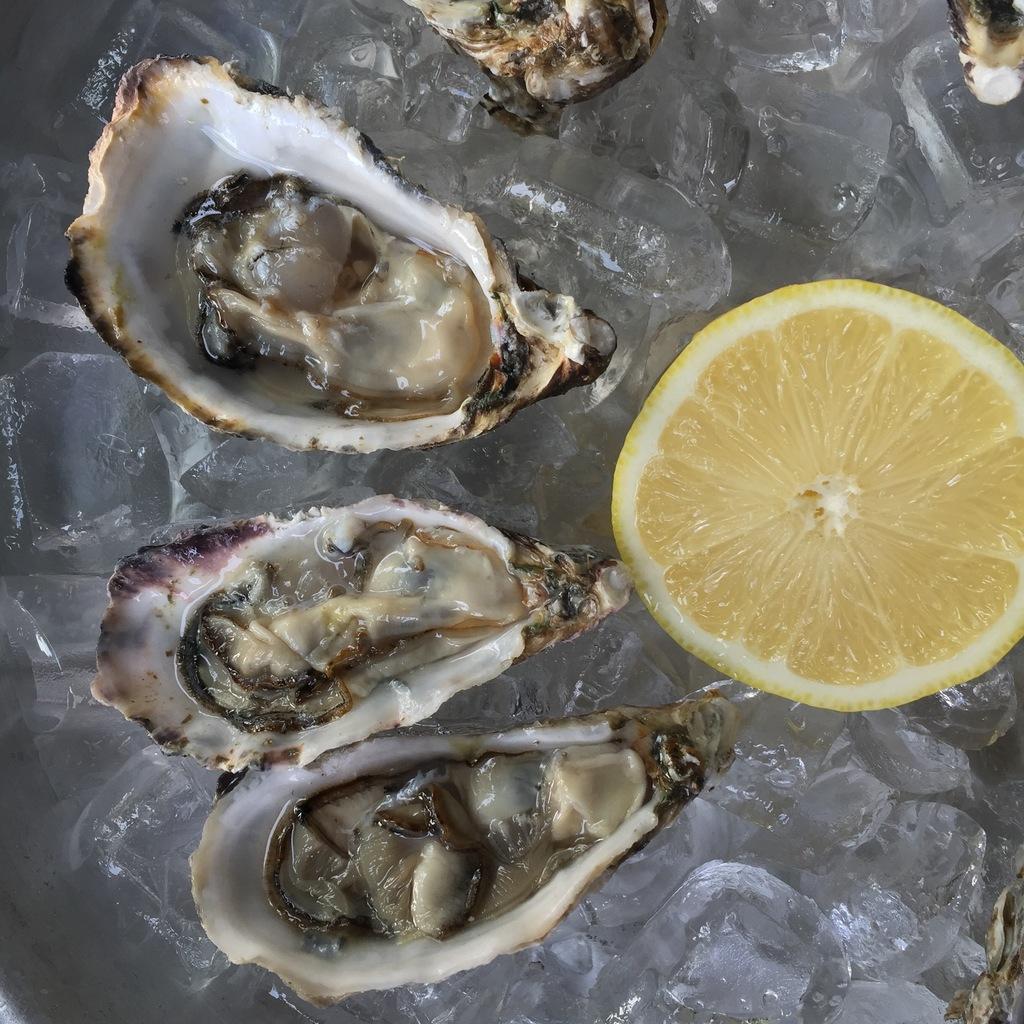How would you summarize this image in a sentence or two? In this image we can see the sea food and also the lemon. In the background we can see the ice. 